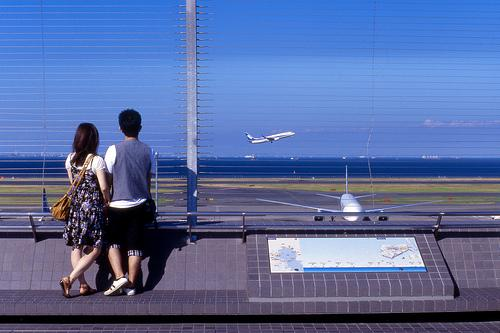Provide a brief description of the man's clothing items in the image. The man is wearing a jacket around his waist, black and grey shorts, and black and white sneakers. What is the primary activity taking place in the image? People are watching planes taking off from the airport. Identify the location of the image and describe any barriers observed. The location is an airport with airplanes on tarmac and a metal wire barrier fence separating people from the planes. Mention a few objects that are visible in the sky. A jetliner and a crystal blue sky without clouds are visible. Describe the appearance of the woman's dress and the accessory she's wearing. The woman is wearing a flower print or floral print dress, a brown leather purse or hobo bag over her shoulder. What are the man and woman doing in regard to their feet? The man and woman both have one foot raised each, likely indicating motion or excitement. Describe the infrastructure elements present in the image. A brick wall, guard rail, support column for the window, and paved airfield surrounded by grass are present. How many airplanes can you see in the image? Two airplanes are shown in the image. Evaluate the image quality based on visible details. The image quality appears to be high, as numerous objects and details are clearly visible and distinguishable. Discuss the general sentiment conveyed by the image. The image conveys a sense of leisure, curiosity, and fascination as the couple watches planes taking off. What is the interaction between the couple and the airplanes in the image? The couple is watching the airplanes taking off. Is the airplane flying in the sky green? The airplane is not described as green in any of the image details, so this instruction would be misleading by implying that it's green when it isn't mentioned in the image information. Can you see tall skyscrapers in the city in the distance? The city in the distance is only described by its position (X:0 Y:147 Width:42 Height:42), but there is no explicit mention of tall skyscrapers. This instruction is misleading by implying that there are skyscrapers in the image when they aren't described in the information. Are there any textual contents in the image that require OCR? No textual contents detected in the image. Assess the quality of this image. The image is of high quality with clear details and no noise. What type of shoes is the man wearing? Black and white sneakers. How is the airplane positioned on the tarmac? Parked. Is the man wearing a bright pink jacket around his waist? The information only states that the man is wearing a jacket, but it doesn't mention its color. By suggesting that it's bright pink, this instruction would be misleading. Find the textual description of the object at position X:49 Y:194 with Width:25 Height:25. a brown leather purse Are there any abnormalities in the image? No abnormalities detected in the image. Are the people standing in front of a large fence built of glass? The image information only mentions a metal wire barrier fence (X:3 Y:3 Width:492 Height:492). By suggesting that the fence is made of glass, this instruction is misleading as it contradicts the information provided. Is the sky clear or cloudy in the image? Clear and blue. Describe the image with a single sentence. A couple is watching airplanes take off while standing near a brick wall under a clear blue sky. Identify the position and dimension of the man in the image. X:104 Y:87 Width:80 Height:80 What color is the purse worn by the woman? Brown. Locate the man and woman in the image observing the plane taking off. Man: X:101 Y:105 Width:77 Height:77; Woman: X:61 Y:123 Width:48 Height:48 What is the material of the barrier fence? Metal wire. Is the woman wearing a floral dress standing against a graffiti-covered wall? The information mentions a section of a brick wall (X:241 Y:227 Width:202 Height:202), but there is no reference to graffiti. This instruction would be misleading as it implies that there is graffiti present when it isn't mentioned in the image information. Identify the objects and their respective positions in the image. A man: X:104 Y:87 Width:80 Height:80; A woman: X:57 Y:114 Width:60 Height:60; A brick wall: X:241 Y:227 Width:202 Height:202  What is the woman doing in the image? Watching a plane take off. Identify the position of the parked white plane at the airport. X:310 Y:182 Width:65 Height:65 How many airplanes are shown in the image? Two airplanes. Is there any text on the map inside the console? No text is visible. Is the crystal blue sky filled with clouds? Multiple instances in the image details mention a blue sky without clouds, so this instruction would be misleading by questioning whether there are clouds present. Describe the emotion behind the image. A sense of enjoyment and wonder as the couple watches the planes. Describe the dress worn by the woman in the image. Floral print dress. 